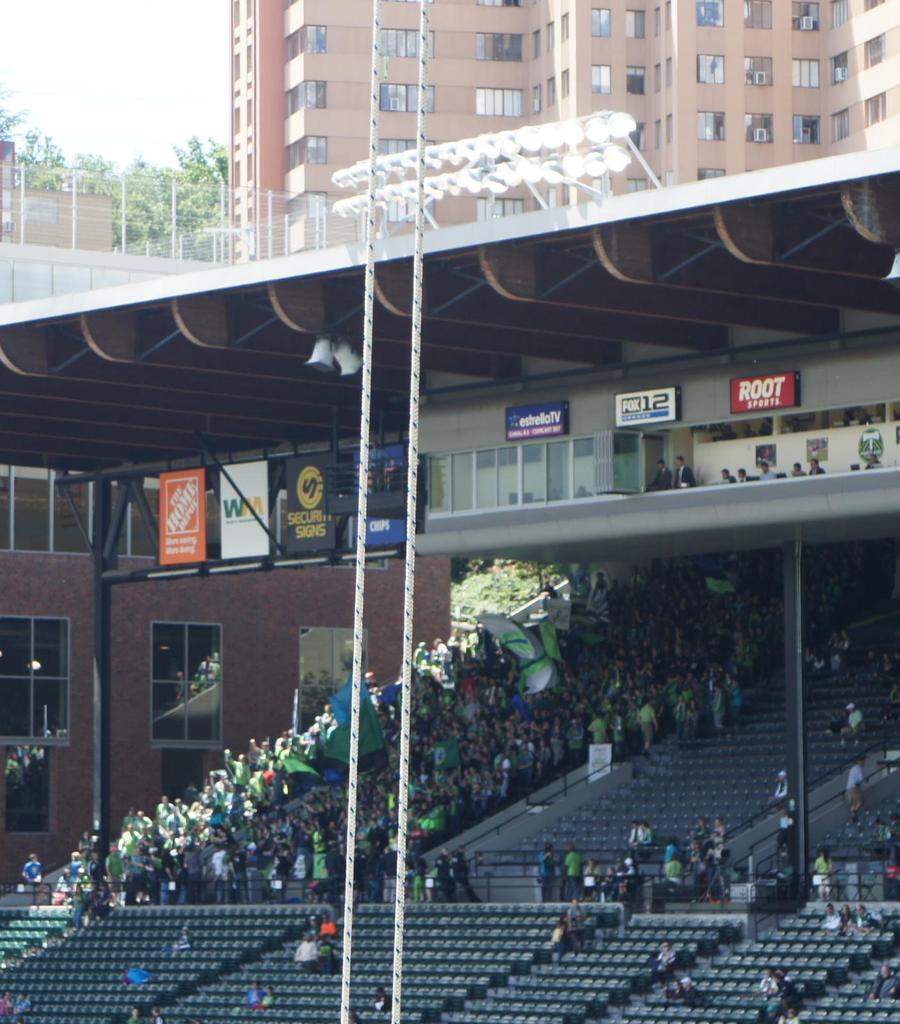Where was the image taken? The image was taken in a stadium. What are the people in the image doing? People are sitting on chairs in the stadium. What can be seen in the background of the image? There is a building in the background of the image. How many cobwebs can be seen hanging from the chairs in the image? There are no cobwebs visible in the image; the chairs appear to be clean and well-maintained. 